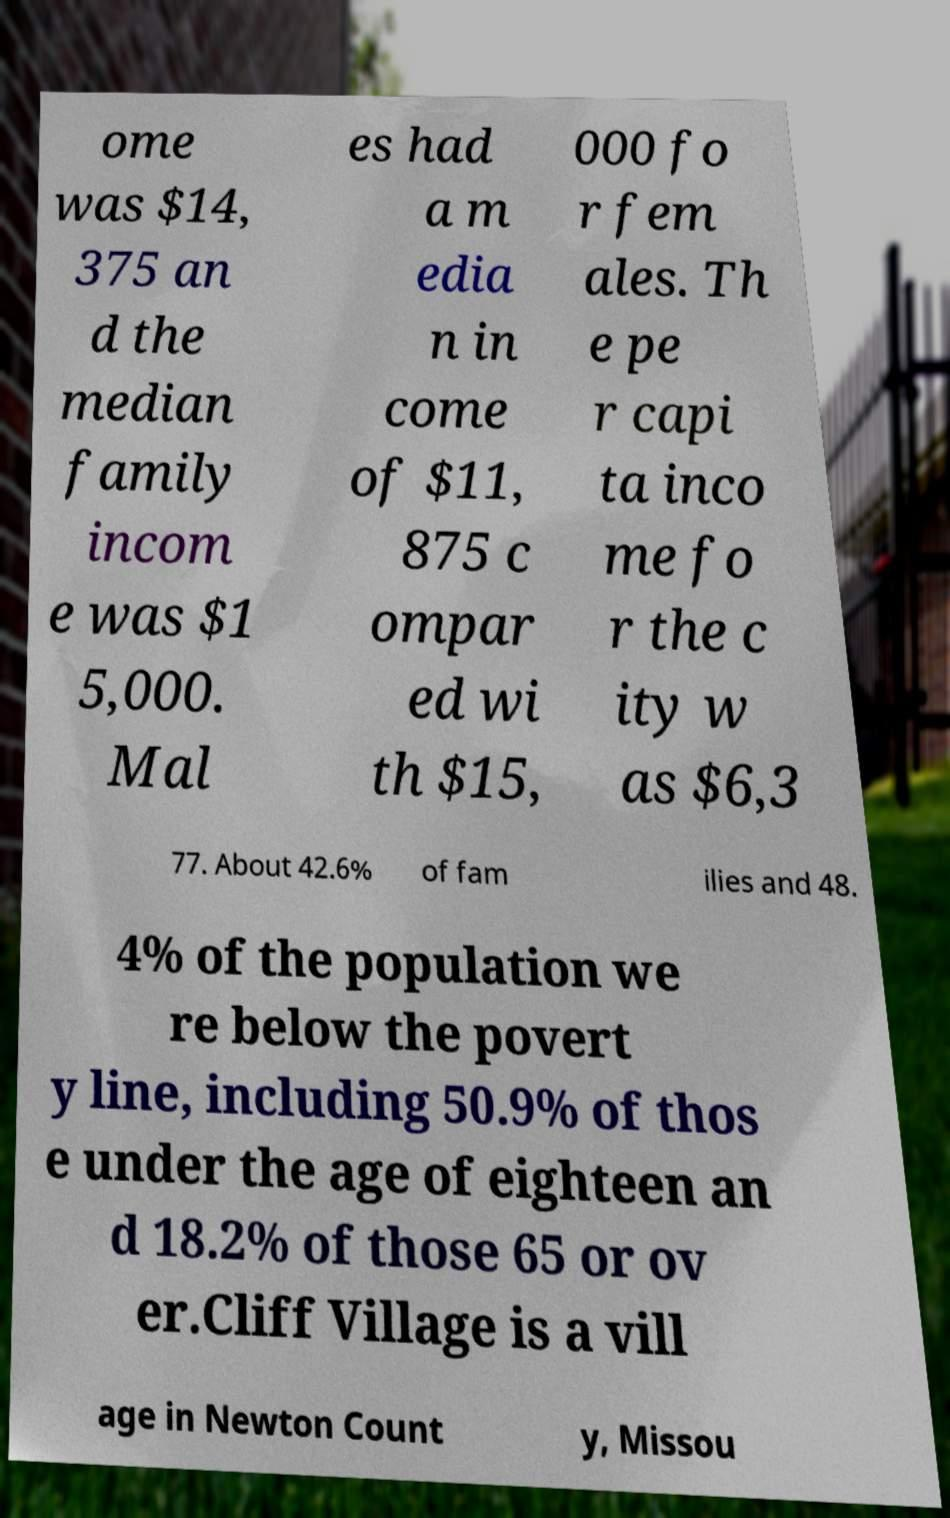There's text embedded in this image that I need extracted. Can you transcribe it verbatim? ome was $14, 375 an d the median family incom e was $1 5,000. Mal es had a m edia n in come of $11, 875 c ompar ed wi th $15, 000 fo r fem ales. Th e pe r capi ta inco me fo r the c ity w as $6,3 77. About 42.6% of fam ilies and 48. 4% of the population we re below the povert y line, including 50.9% of thos e under the age of eighteen an d 18.2% of those 65 or ov er.Cliff Village is a vill age in Newton Count y, Missou 